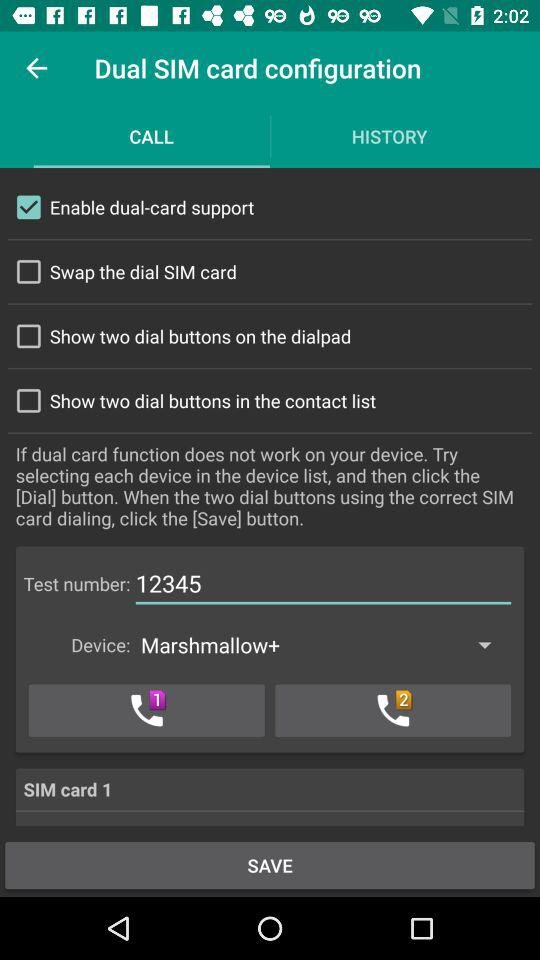Which SIM card is selected? The selected SIM card is 1. 